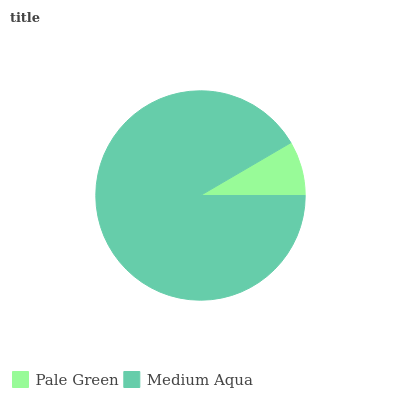Is Pale Green the minimum?
Answer yes or no. Yes. Is Medium Aqua the maximum?
Answer yes or no. Yes. Is Medium Aqua the minimum?
Answer yes or no. No. Is Medium Aqua greater than Pale Green?
Answer yes or no. Yes. Is Pale Green less than Medium Aqua?
Answer yes or no. Yes. Is Pale Green greater than Medium Aqua?
Answer yes or no. No. Is Medium Aqua less than Pale Green?
Answer yes or no. No. Is Medium Aqua the high median?
Answer yes or no. Yes. Is Pale Green the low median?
Answer yes or no. Yes. Is Pale Green the high median?
Answer yes or no. No. Is Medium Aqua the low median?
Answer yes or no. No. 